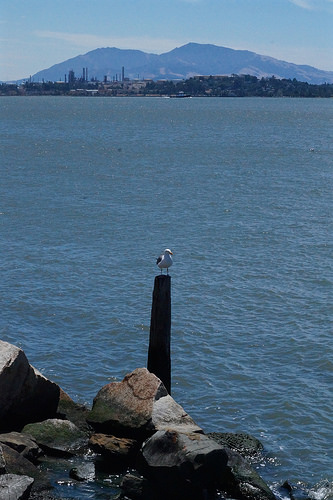<image>
Is there a mountain next to the bird? No. The mountain is not positioned next to the bird. They are located in different areas of the scene. 